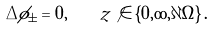<formula> <loc_0><loc_0><loc_500><loc_500>\Delta \phi _ { \pm } = 0 , \quad z \not \in \left \{ 0 , \infty , \partial \Omega \right \} .</formula> 